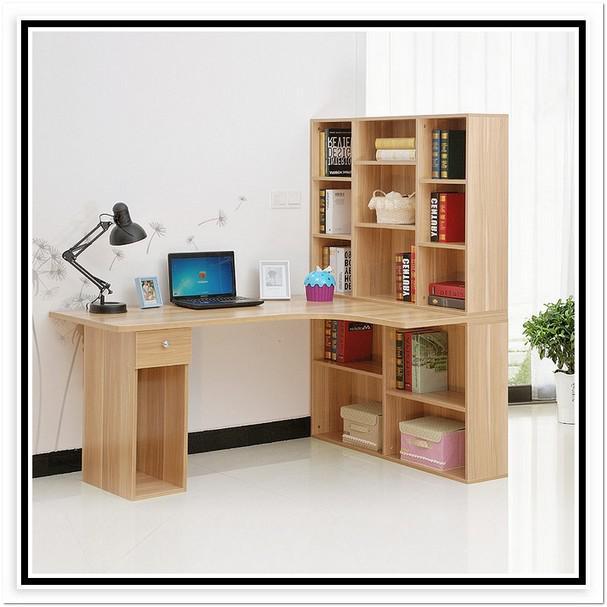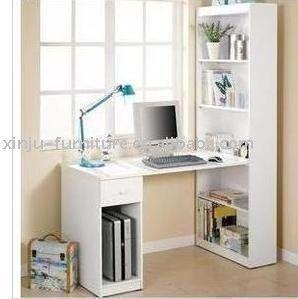The first image is the image on the left, the second image is the image on the right. Evaluate the accuracy of this statement regarding the images: "there is a built in desk and wall shelves with a desk chair at the desk". Is it true? Answer yes or no. No. The first image is the image on the left, the second image is the image on the right. Considering the images on both sides, is "In one of the photos, there is a potted plant sitting on a shelf." valid? Answer yes or no. Yes. 